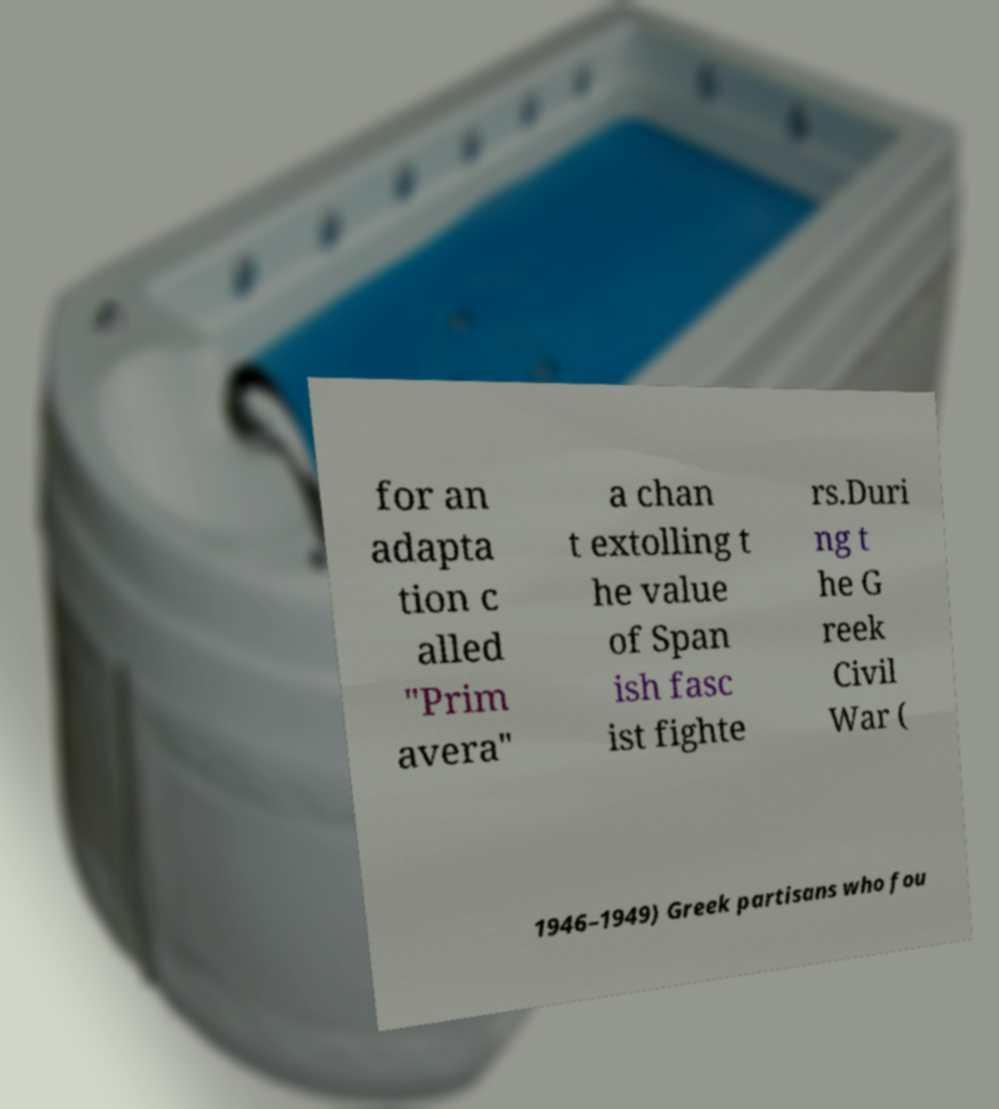Could you assist in decoding the text presented in this image and type it out clearly? for an adapta tion c alled "Prim avera" a chan t extolling t he value of Span ish fasc ist fighte rs.Duri ng t he G reek Civil War ( 1946–1949) Greek partisans who fou 